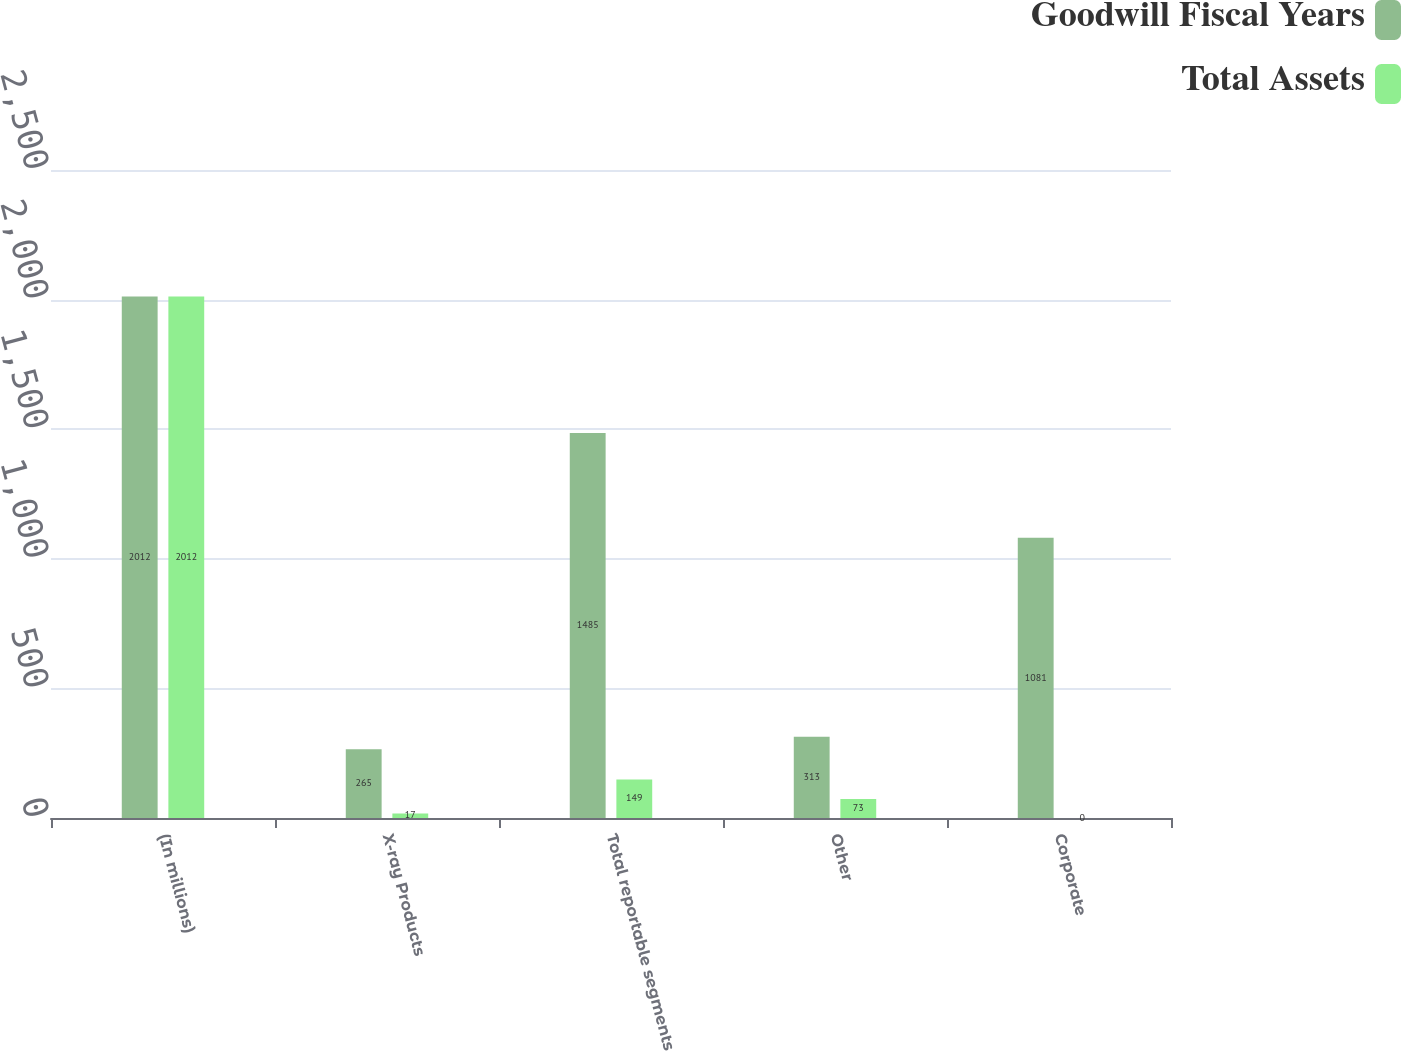Convert chart. <chart><loc_0><loc_0><loc_500><loc_500><stacked_bar_chart><ecel><fcel>(In millions)<fcel>X-ray Products<fcel>Total reportable segments<fcel>Other<fcel>Corporate<nl><fcel>Goodwill Fiscal Years<fcel>2012<fcel>265<fcel>1485<fcel>313<fcel>1081<nl><fcel>Total Assets<fcel>2012<fcel>17<fcel>149<fcel>73<fcel>0<nl></chart> 